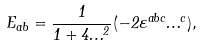Convert formula to latex. <formula><loc_0><loc_0><loc_500><loc_500>E _ { a b } = \frac { 1 } { 1 + 4 \Phi ^ { 2 } } ( - 2 \varepsilon ^ { a b c } \Phi ^ { c } ) ,</formula> 